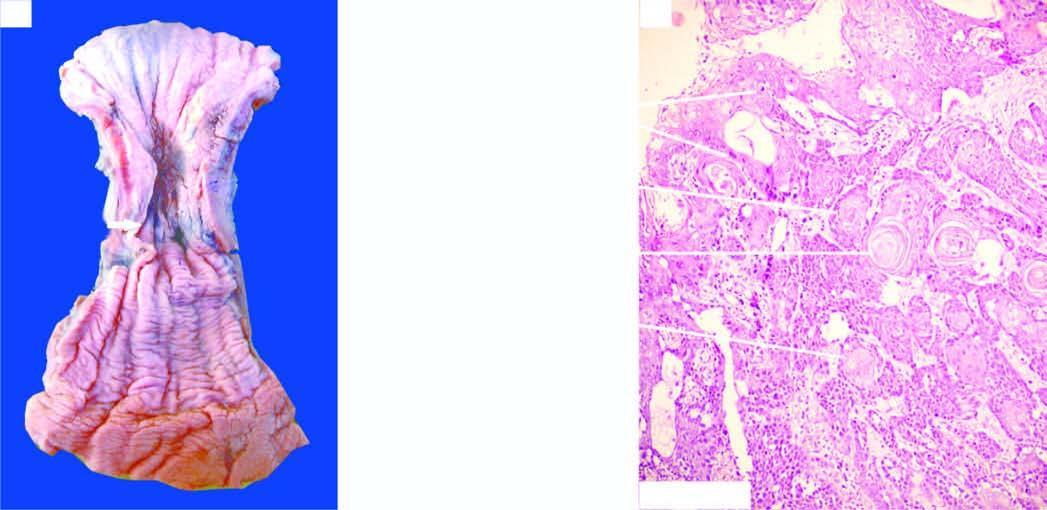what is there thickening in the middle causing narrowing of the lumen?
Answer the question using a single word or phrase. A concentric circumferential 